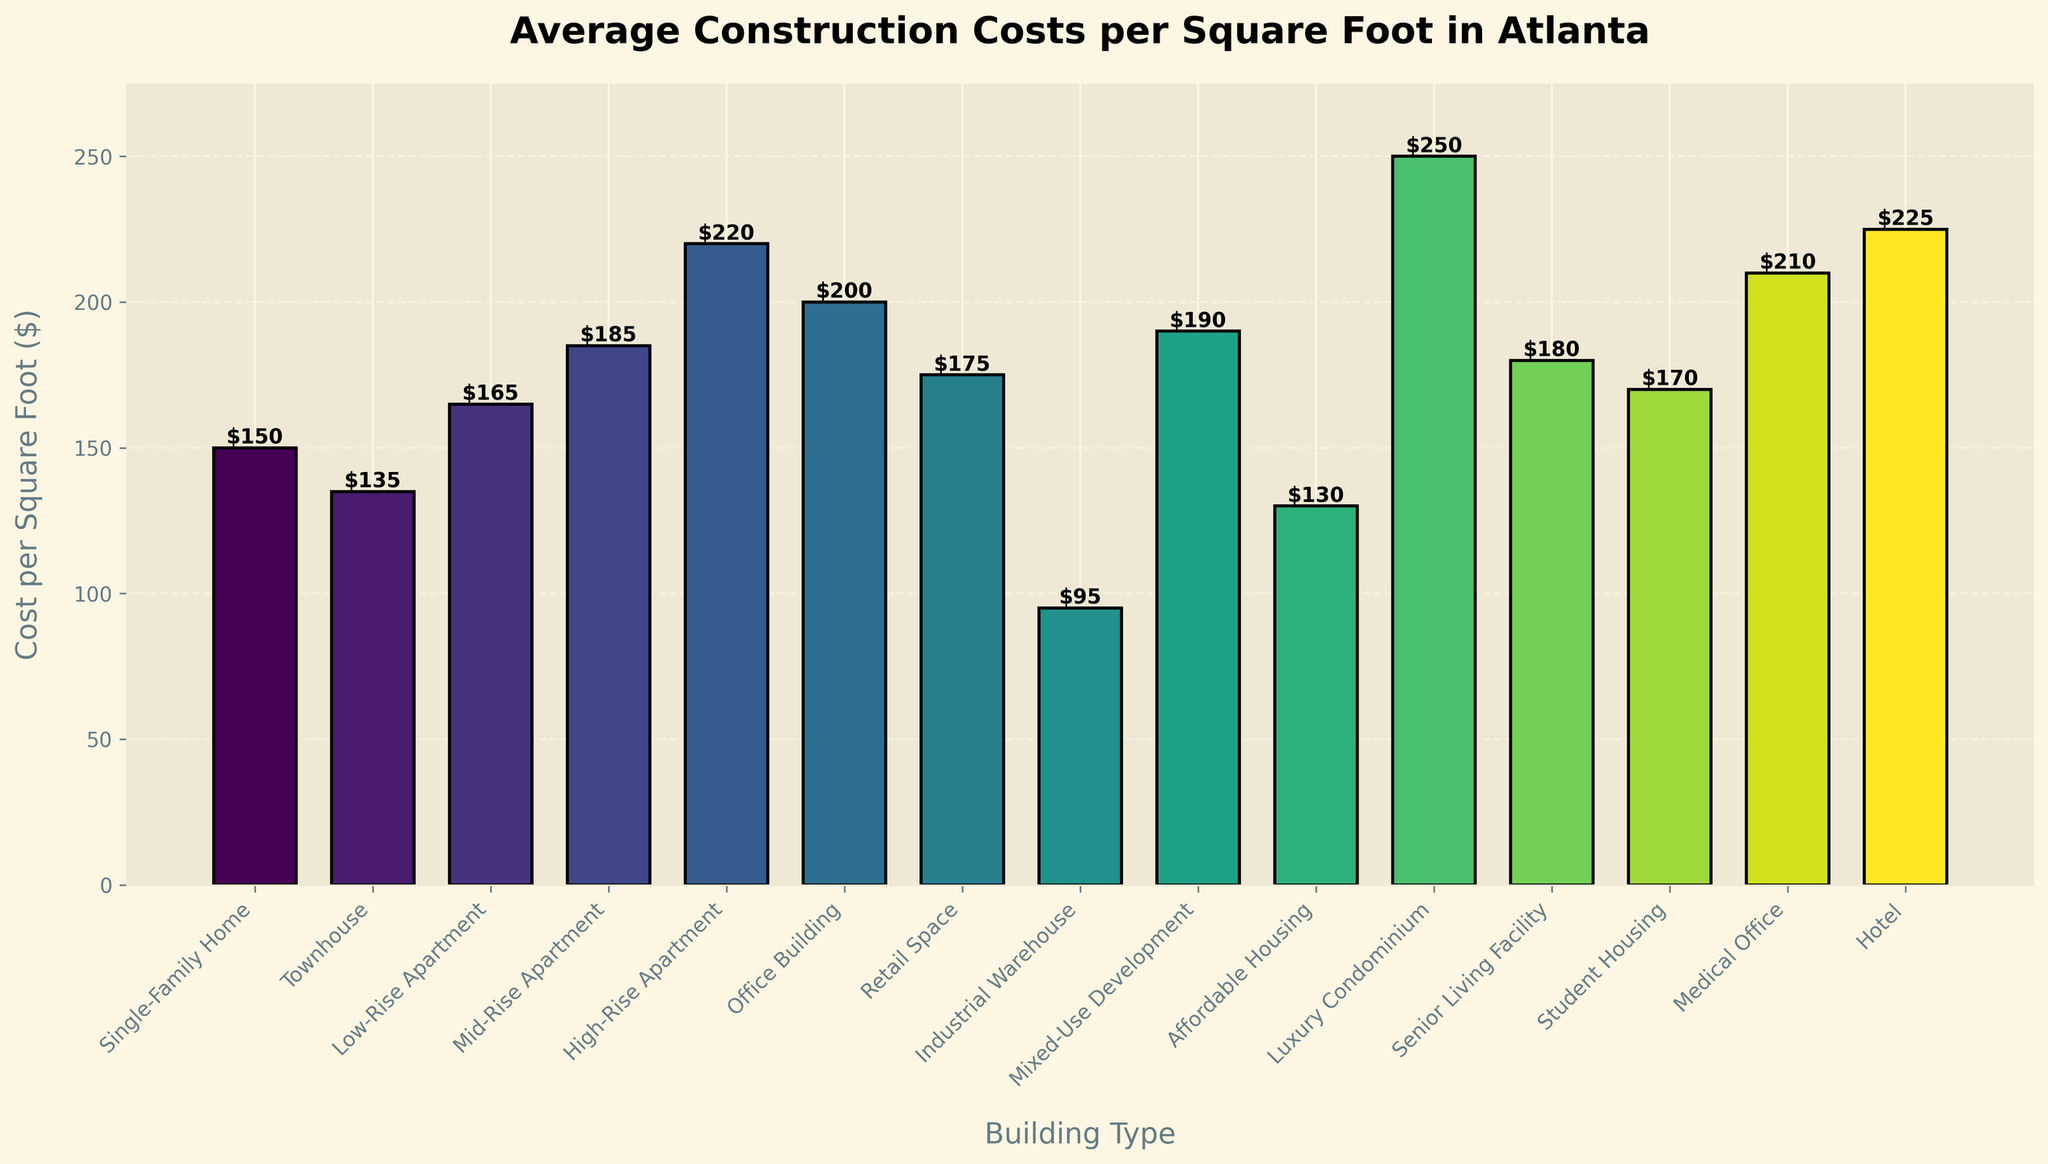What building type has the highest construction cost per square foot? Identify the highest bar in the chart, which represents the highest construction cost per square foot.
Answer: Luxury Condominium What is the cost difference per square foot between a High-Rise Apartment and an Industrial Warehouse? Find the height of the bars for High-Rise Apartment and Industrial Warehouse, then subtract the lower value from the higher value: $220 - $95.
Answer: $125 Which type of building has the lowest construction cost per square foot? Locate the shortest bar in the chart, which represents the lowest construction cost per square foot.
Answer: Industrial Warehouse What is the combined cost per square foot of constructing a Single-Family Home, a Townhouse, and a Low-Rise Apartment? Sum the heights of the bars for Single-Family Home, Townhouse, and Low-Rise Apartment: 150 + 135 + 165.
Answer: $450 How much more expensive per square foot is constructing a Medical Office compared to Affordable Housing? Find the height of the bars for Medical Office and Affordable Housing, then subtract the height of the bar for Affordable Housing from Medical Office: $210 - $130.
Answer: $80 Which building type is more expensive to construct per square foot: a Hotel or a Retail Space? Compare the height of the bars for Hotel and Retail Space. The bar for Hotel is taller than the bar for Retail Space.
Answer: Hotel Rank the top three most expensive building types to construct per square foot. Identify the three tallest bars in the chart. They represent the top three most expensive building types.
Answer: Luxury Condominium, Hotel, Medical Office What is the average construction cost per square foot for Mid-Rise Apartments, High-Rise Apartments, and Mixed-Use Developments? Sum the heights of the bars for Mid-Rise Apartments, High-Rise Apartments, and Mixed-Use Developments, then divide by 3: (185 + 220 + 190) / 3.
Answer: $198.33 By how much does the cost per square foot of constructing a Student Housing exceed that of an Affordable Housing? Find the heights of the bars for Student Housing and Affordable Housing, then subtract the height of Affordable Housing from Student Housing: $170 - $130.
Answer: $40 Which type of building has similar construction costs per square foot to a Mid-Rise Apartment? Locate the bar for Mid-Rise Apartment and identify any bars with similar height. The bar for Senior Living Facility is close in height to Mid-Rise Apartment.
Answer: Senior Living Facility 